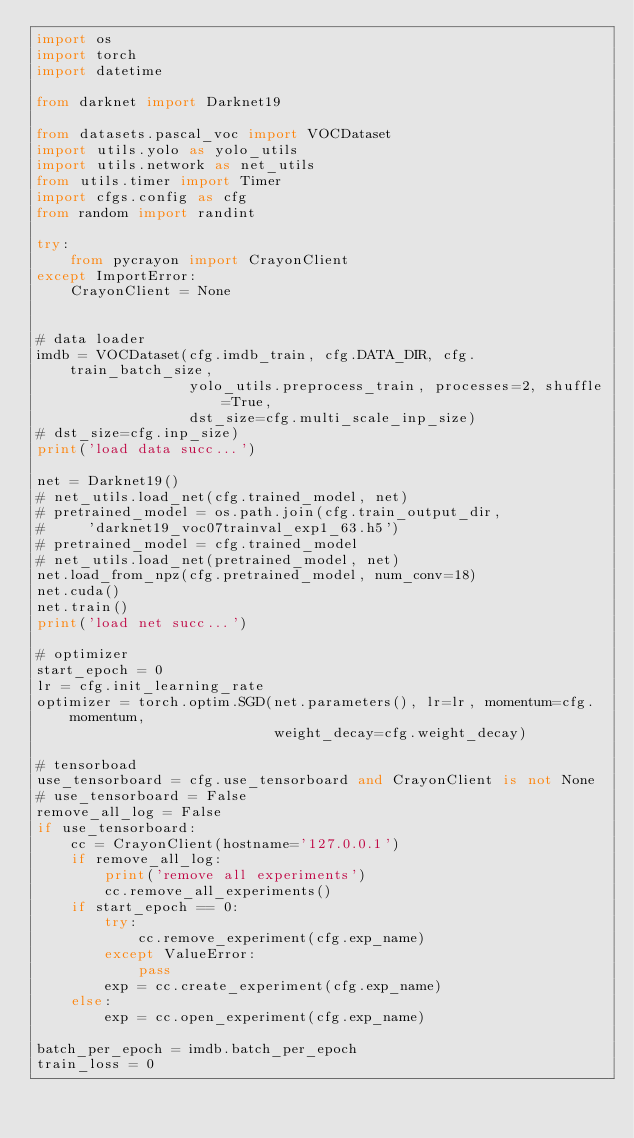<code> <loc_0><loc_0><loc_500><loc_500><_Python_>import os
import torch
import datetime

from darknet import Darknet19

from datasets.pascal_voc import VOCDataset
import utils.yolo as yolo_utils
import utils.network as net_utils
from utils.timer import Timer
import cfgs.config as cfg
from random import randint

try:
    from pycrayon import CrayonClient
except ImportError:
    CrayonClient = None


# data loader
imdb = VOCDataset(cfg.imdb_train, cfg.DATA_DIR, cfg.train_batch_size,
                  yolo_utils.preprocess_train, processes=2, shuffle=True,
                  dst_size=cfg.multi_scale_inp_size)
# dst_size=cfg.inp_size)
print('load data succ...')

net = Darknet19()
# net_utils.load_net(cfg.trained_model, net)
# pretrained_model = os.path.join(cfg.train_output_dir,
#     'darknet19_voc07trainval_exp1_63.h5')
# pretrained_model = cfg.trained_model
# net_utils.load_net(pretrained_model, net)
net.load_from_npz(cfg.pretrained_model, num_conv=18)
net.cuda()
net.train()
print('load net succ...')

# optimizer
start_epoch = 0
lr = cfg.init_learning_rate
optimizer = torch.optim.SGD(net.parameters(), lr=lr, momentum=cfg.momentum,
                            weight_decay=cfg.weight_decay)

# tensorboad
use_tensorboard = cfg.use_tensorboard and CrayonClient is not None
# use_tensorboard = False
remove_all_log = False
if use_tensorboard:
    cc = CrayonClient(hostname='127.0.0.1')
    if remove_all_log:
        print('remove all experiments')
        cc.remove_all_experiments()
    if start_epoch == 0:
        try:
            cc.remove_experiment(cfg.exp_name)
        except ValueError:
            pass
        exp = cc.create_experiment(cfg.exp_name)
    else:
        exp = cc.open_experiment(cfg.exp_name)

batch_per_epoch = imdb.batch_per_epoch
train_loss = 0</code> 